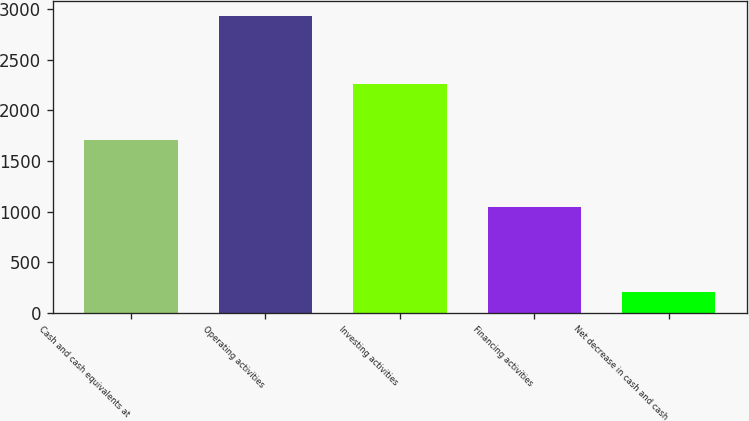Convert chart to OTSL. <chart><loc_0><loc_0><loc_500><loc_500><bar_chart><fcel>Cash and cash equivalents at<fcel>Operating activities<fcel>Investing activities<fcel>Financing activities<fcel>Net decrease in cash and cash<nl><fcel>1710<fcel>2933<fcel>2254.6<fcel>1048<fcel>210<nl></chart> 